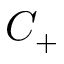Convert formula to latex. <formula><loc_0><loc_0><loc_500><loc_500>C _ { + }</formula> 